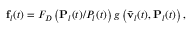<formula> <loc_0><loc_0><loc_500><loc_500>{ f } _ { l } ( t ) = F _ { D } \left ( { { P } _ { l } ( t ) } / { P _ { l } ( t ) } \right ) g \left ( \bar { v } _ { l } ( t ) , { P } _ { l } ( t ) \right ) ,</formula> 